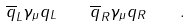<formula> <loc_0><loc_0><loc_500><loc_500>\overline { q } _ { L } \gamma _ { \mu } q _ { L } \quad \overline { q } _ { R } \gamma _ { \mu } q _ { R } \quad .</formula> 